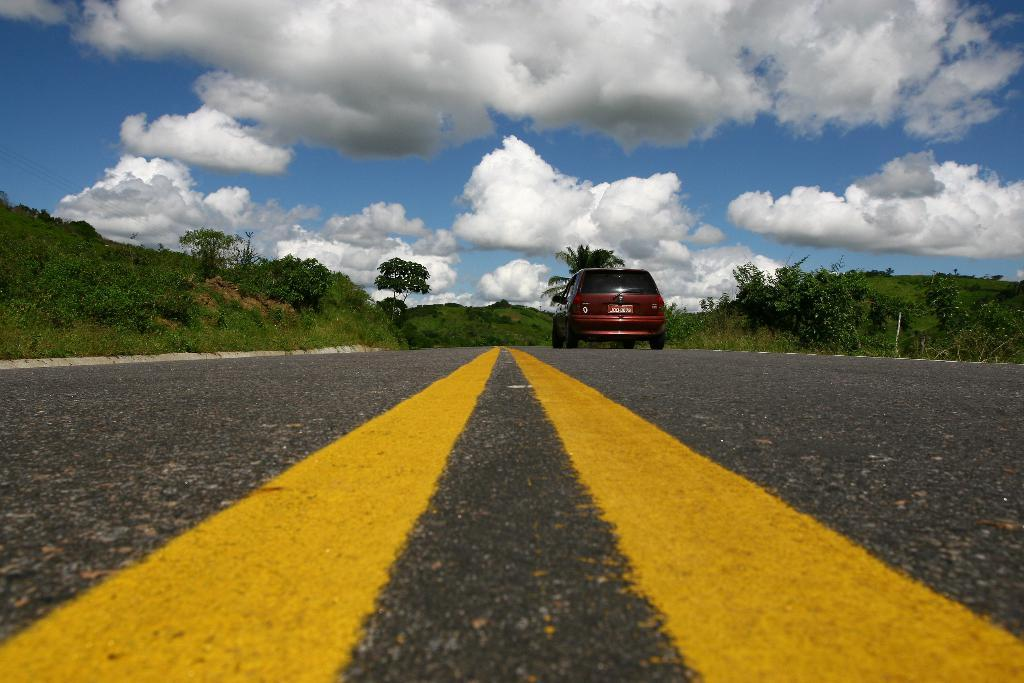What is the color of the sky in the background of the image? The sky in the background of the image is clear blue with clouds. What can be seen on either side of the road in the image? There are trees and grass on either side of the road in the image. What markings are visible on the road? There are yellow lines on the road. What type of vehicle is present on the road? There is a red car on the road. What type of drug is being advertised on the red car in the image? There is no drug being advertised on the red car in the image; it is simply a red car on the road. 